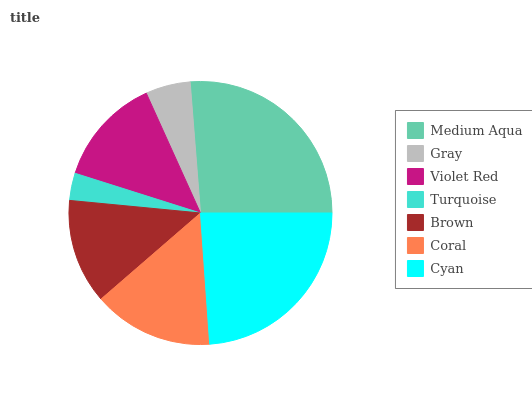Is Turquoise the minimum?
Answer yes or no. Yes. Is Medium Aqua the maximum?
Answer yes or no. Yes. Is Gray the minimum?
Answer yes or no. No. Is Gray the maximum?
Answer yes or no. No. Is Medium Aqua greater than Gray?
Answer yes or no. Yes. Is Gray less than Medium Aqua?
Answer yes or no. Yes. Is Gray greater than Medium Aqua?
Answer yes or no. No. Is Medium Aqua less than Gray?
Answer yes or no. No. Is Violet Red the high median?
Answer yes or no. Yes. Is Violet Red the low median?
Answer yes or no. Yes. Is Medium Aqua the high median?
Answer yes or no. No. Is Coral the low median?
Answer yes or no. No. 